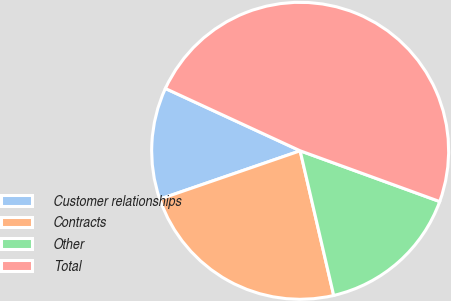Convert chart. <chart><loc_0><loc_0><loc_500><loc_500><pie_chart><fcel>Customer relationships<fcel>Contracts<fcel>Other<fcel>Total<nl><fcel>12.17%<fcel>23.35%<fcel>15.82%<fcel>48.66%<nl></chart> 